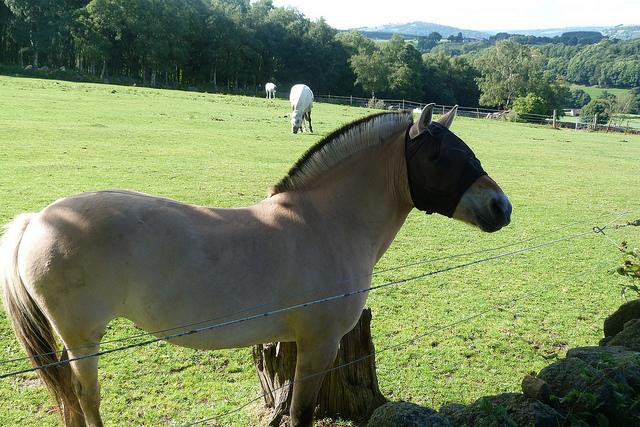How many horses?
Keep it brief. 3. Do all of the animals in the picture graze?
Be succinct. Yes. Is the horse multicolored?
Answer briefly. No. Where is the fence?
Answer briefly. By horse. How many eyes are shown?
Give a very brief answer. 1. Is barbed wire present?
Quick response, please. Yes. Does the animal have horns?
Concise answer only. No. 